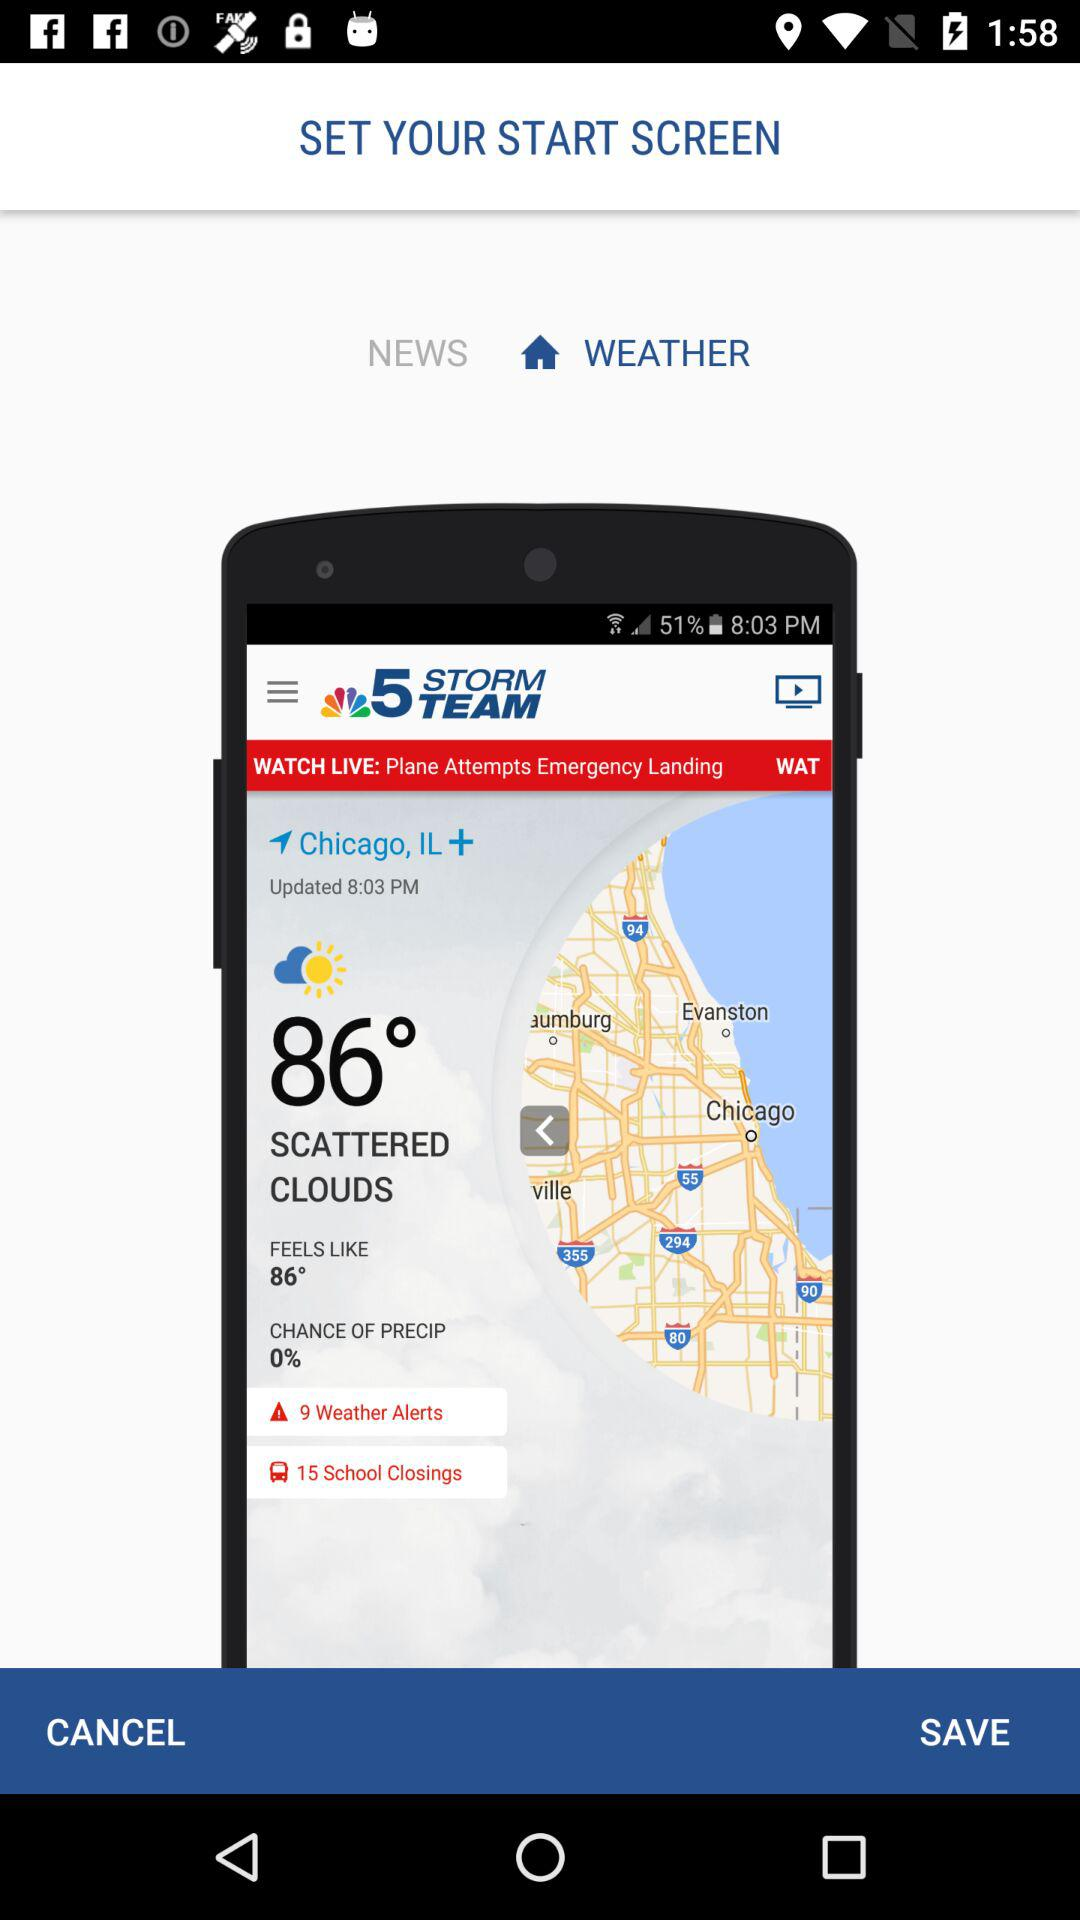Which start screen is selected? The selected start screen is "WEATHER". 